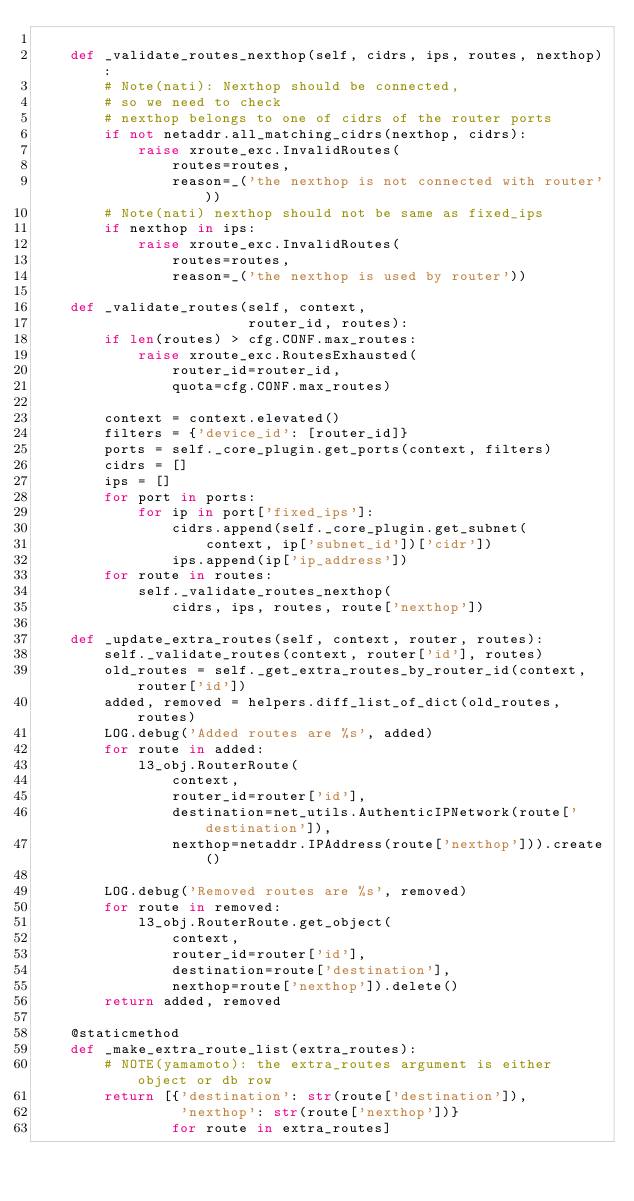Convert code to text. <code><loc_0><loc_0><loc_500><loc_500><_Python_>
    def _validate_routes_nexthop(self, cidrs, ips, routes, nexthop):
        # Note(nati): Nexthop should be connected,
        # so we need to check
        # nexthop belongs to one of cidrs of the router ports
        if not netaddr.all_matching_cidrs(nexthop, cidrs):
            raise xroute_exc.InvalidRoutes(
                routes=routes,
                reason=_('the nexthop is not connected with router'))
        # Note(nati) nexthop should not be same as fixed_ips
        if nexthop in ips:
            raise xroute_exc.InvalidRoutes(
                routes=routes,
                reason=_('the nexthop is used by router'))

    def _validate_routes(self, context,
                         router_id, routes):
        if len(routes) > cfg.CONF.max_routes:
            raise xroute_exc.RoutesExhausted(
                router_id=router_id,
                quota=cfg.CONF.max_routes)

        context = context.elevated()
        filters = {'device_id': [router_id]}
        ports = self._core_plugin.get_ports(context, filters)
        cidrs = []
        ips = []
        for port in ports:
            for ip in port['fixed_ips']:
                cidrs.append(self._core_plugin.get_subnet(
                    context, ip['subnet_id'])['cidr'])
                ips.append(ip['ip_address'])
        for route in routes:
            self._validate_routes_nexthop(
                cidrs, ips, routes, route['nexthop'])

    def _update_extra_routes(self, context, router, routes):
        self._validate_routes(context, router['id'], routes)
        old_routes = self._get_extra_routes_by_router_id(context, router['id'])
        added, removed = helpers.diff_list_of_dict(old_routes, routes)
        LOG.debug('Added routes are %s', added)
        for route in added:
            l3_obj.RouterRoute(
                context,
                router_id=router['id'],
                destination=net_utils.AuthenticIPNetwork(route['destination']),
                nexthop=netaddr.IPAddress(route['nexthop'])).create()

        LOG.debug('Removed routes are %s', removed)
        for route in removed:
            l3_obj.RouterRoute.get_object(
                context,
                router_id=router['id'],
                destination=route['destination'],
                nexthop=route['nexthop']).delete()
        return added, removed

    @staticmethod
    def _make_extra_route_list(extra_routes):
        # NOTE(yamamoto): the extra_routes argument is either object or db row
        return [{'destination': str(route['destination']),
                 'nexthop': str(route['nexthop'])}
                for route in extra_routes]
</code> 